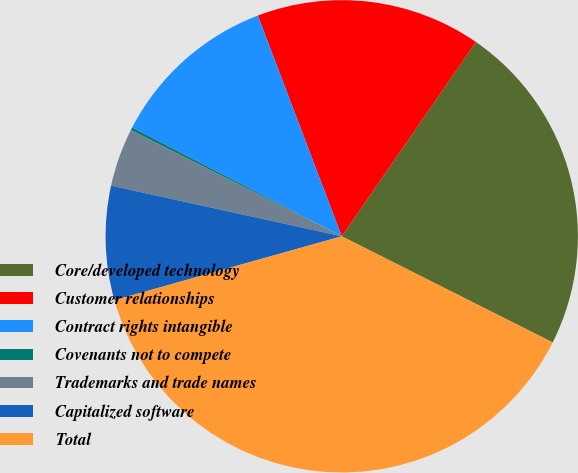Convert chart. <chart><loc_0><loc_0><loc_500><loc_500><pie_chart><fcel>Core/developed technology<fcel>Customer relationships<fcel>Contract rights intangible<fcel>Covenants not to compete<fcel>Trademarks and trade names<fcel>Capitalized software<fcel>Total<nl><fcel>22.8%<fcel>15.4%<fcel>11.6%<fcel>0.19%<fcel>3.99%<fcel>7.8%<fcel>38.22%<nl></chart> 